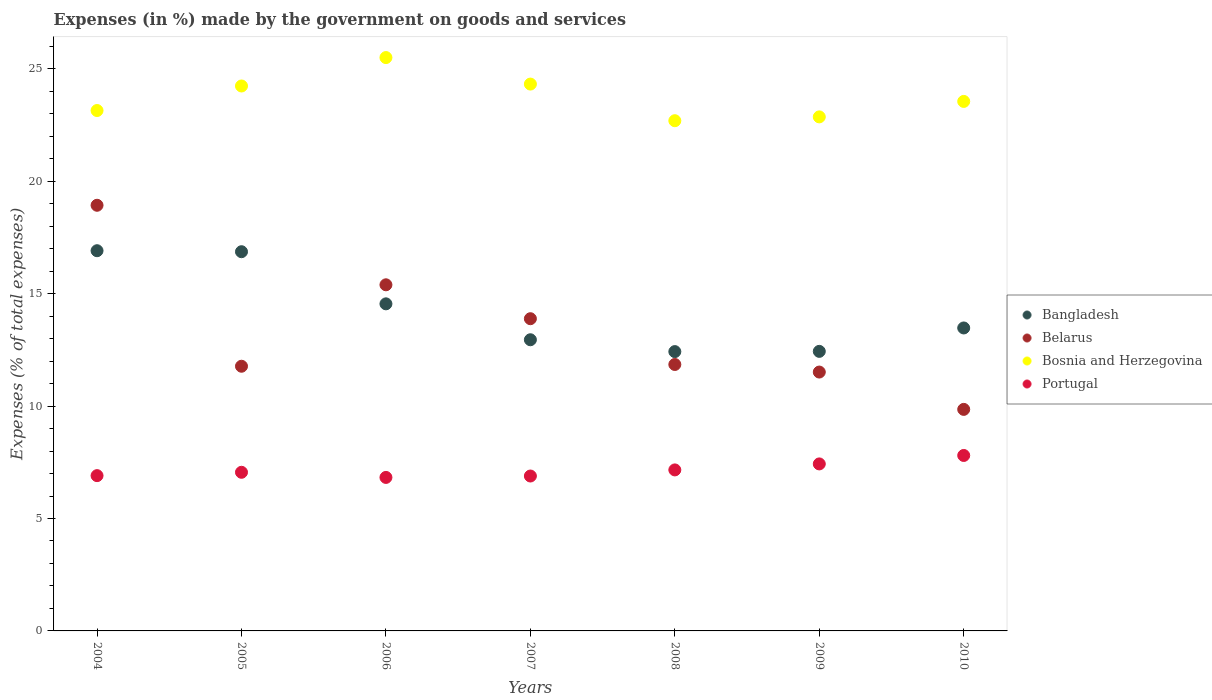Is the number of dotlines equal to the number of legend labels?
Your response must be concise. Yes. What is the percentage of expenses made by the government on goods and services in Belarus in 2007?
Your answer should be very brief. 13.89. Across all years, what is the maximum percentage of expenses made by the government on goods and services in Portugal?
Give a very brief answer. 7.8. Across all years, what is the minimum percentage of expenses made by the government on goods and services in Portugal?
Make the answer very short. 6.83. In which year was the percentage of expenses made by the government on goods and services in Bangladesh maximum?
Your answer should be compact. 2004. In which year was the percentage of expenses made by the government on goods and services in Belarus minimum?
Your response must be concise. 2010. What is the total percentage of expenses made by the government on goods and services in Bangladesh in the graph?
Offer a very short reply. 99.62. What is the difference between the percentage of expenses made by the government on goods and services in Portugal in 2004 and that in 2010?
Ensure brevity in your answer.  -0.9. What is the difference between the percentage of expenses made by the government on goods and services in Bangladesh in 2006 and the percentage of expenses made by the government on goods and services in Bosnia and Herzegovina in 2005?
Offer a very short reply. -9.69. What is the average percentage of expenses made by the government on goods and services in Belarus per year?
Keep it short and to the point. 13.32. In the year 2004, what is the difference between the percentage of expenses made by the government on goods and services in Portugal and percentage of expenses made by the government on goods and services in Bangladesh?
Provide a succinct answer. -10. What is the ratio of the percentage of expenses made by the government on goods and services in Portugal in 2004 to that in 2010?
Your response must be concise. 0.89. What is the difference between the highest and the second highest percentage of expenses made by the government on goods and services in Bangladesh?
Give a very brief answer. 0.04. What is the difference between the highest and the lowest percentage of expenses made by the government on goods and services in Bosnia and Herzegovina?
Offer a terse response. 2.81. In how many years, is the percentage of expenses made by the government on goods and services in Belarus greater than the average percentage of expenses made by the government on goods and services in Belarus taken over all years?
Your answer should be compact. 3. Is the sum of the percentage of expenses made by the government on goods and services in Belarus in 2005 and 2006 greater than the maximum percentage of expenses made by the government on goods and services in Bangladesh across all years?
Make the answer very short. Yes. Is it the case that in every year, the sum of the percentage of expenses made by the government on goods and services in Bosnia and Herzegovina and percentage of expenses made by the government on goods and services in Portugal  is greater than the sum of percentage of expenses made by the government on goods and services in Belarus and percentage of expenses made by the government on goods and services in Bangladesh?
Keep it short and to the point. Yes. Is the percentage of expenses made by the government on goods and services in Belarus strictly greater than the percentage of expenses made by the government on goods and services in Bosnia and Herzegovina over the years?
Your answer should be very brief. No. Is the percentage of expenses made by the government on goods and services in Portugal strictly less than the percentage of expenses made by the government on goods and services in Bosnia and Herzegovina over the years?
Keep it short and to the point. Yes. How many dotlines are there?
Offer a terse response. 4. What is the difference between two consecutive major ticks on the Y-axis?
Provide a short and direct response. 5. Are the values on the major ticks of Y-axis written in scientific E-notation?
Ensure brevity in your answer.  No. Does the graph contain any zero values?
Make the answer very short. No. Where does the legend appear in the graph?
Ensure brevity in your answer.  Center right. How many legend labels are there?
Your answer should be compact. 4. How are the legend labels stacked?
Keep it short and to the point. Vertical. What is the title of the graph?
Offer a terse response. Expenses (in %) made by the government on goods and services. Does "Ecuador" appear as one of the legend labels in the graph?
Give a very brief answer. No. What is the label or title of the Y-axis?
Ensure brevity in your answer.  Expenses (% of total expenses). What is the Expenses (% of total expenses) of Bangladesh in 2004?
Your answer should be very brief. 16.91. What is the Expenses (% of total expenses) of Belarus in 2004?
Offer a terse response. 18.93. What is the Expenses (% of total expenses) in Bosnia and Herzegovina in 2004?
Your answer should be very brief. 23.15. What is the Expenses (% of total expenses) of Portugal in 2004?
Your response must be concise. 6.91. What is the Expenses (% of total expenses) in Bangladesh in 2005?
Your response must be concise. 16.87. What is the Expenses (% of total expenses) of Belarus in 2005?
Your answer should be very brief. 11.77. What is the Expenses (% of total expenses) of Bosnia and Herzegovina in 2005?
Give a very brief answer. 24.24. What is the Expenses (% of total expenses) of Portugal in 2005?
Keep it short and to the point. 7.06. What is the Expenses (% of total expenses) of Bangladesh in 2006?
Ensure brevity in your answer.  14.55. What is the Expenses (% of total expenses) in Belarus in 2006?
Give a very brief answer. 15.4. What is the Expenses (% of total expenses) of Bosnia and Herzegovina in 2006?
Provide a succinct answer. 25.5. What is the Expenses (% of total expenses) of Portugal in 2006?
Keep it short and to the point. 6.83. What is the Expenses (% of total expenses) of Bangladesh in 2007?
Your response must be concise. 12.95. What is the Expenses (% of total expenses) of Belarus in 2007?
Offer a terse response. 13.89. What is the Expenses (% of total expenses) of Bosnia and Herzegovina in 2007?
Offer a terse response. 24.32. What is the Expenses (% of total expenses) of Portugal in 2007?
Give a very brief answer. 6.89. What is the Expenses (% of total expenses) in Bangladesh in 2008?
Offer a very short reply. 12.42. What is the Expenses (% of total expenses) of Belarus in 2008?
Your response must be concise. 11.85. What is the Expenses (% of total expenses) in Bosnia and Herzegovina in 2008?
Keep it short and to the point. 22.7. What is the Expenses (% of total expenses) of Portugal in 2008?
Your response must be concise. 7.16. What is the Expenses (% of total expenses) in Bangladesh in 2009?
Your response must be concise. 12.44. What is the Expenses (% of total expenses) in Belarus in 2009?
Your response must be concise. 11.51. What is the Expenses (% of total expenses) in Bosnia and Herzegovina in 2009?
Offer a very short reply. 22.87. What is the Expenses (% of total expenses) of Portugal in 2009?
Ensure brevity in your answer.  7.43. What is the Expenses (% of total expenses) in Bangladesh in 2010?
Your answer should be very brief. 13.48. What is the Expenses (% of total expenses) of Belarus in 2010?
Your answer should be very brief. 9.85. What is the Expenses (% of total expenses) of Bosnia and Herzegovina in 2010?
Ensure brevity in your answer.  23.55. What is the Expenses (% of total expenses) of Portugal in 2010?
Keep it short and to the point. 7.8. Across all years, what is the maximum Expenses (% of total expenses) of Bangladesh?
Your answer should be very brief. 16.91. Across all years, what is the maximum Expenses (% of total expenses) in Belarus?
Make the answer very short. 18.93. Across all years, what is the maximum Expenses (% of total expenses) of Bosnia and Herzegovina?
Offer a very short reply. 25.5. Across all years, what is the maximum Expenses (% of total expenses) of Portugal?
Offer a terse response. 7.8. Across all years, what is the minimum Expenses (% of total expenses) of Bangladesh?
Provide a short and direct response. 12.42. Across all years, what is the minimum Expenses (% of total expenses) of Belarus?
Offer a very short reply. 9.85. Across all years, what is the minimum Expenses (% of total expenses) in Bosnia and Herzegovina?
Provide a short and direct response. 22.7. Across all years, what is the minimum Expenses (% of total expenses) in Portugal?
Provide a succinct answer. 6.83. What is the total Expenses (% of total expenses) of Bangladesh in the graph?
Your response must be concise. 99.62. What is the total Expenses (% of total expenses) in Belarus in the graph?
Keep it short and to the point. 93.21. What is the total Expenses (% of total expenses) of Bosnia and Herzegovina in the graph?
Make the answer very short. 166.33. What is the total Expenses (% of total expenses) in Portugal in the graph?
Keep it short and to the point. 50.08. What is the difference between the Expenses (% of total expenses) of Bangladesh in 2004 and that in 2005?
Your response must be concise. 0.04. What is the difference between the Expenses (% of total expenses) of Belarus in 2004 and that in 2005?
Offer a very short reply. 7.16. What is the difference between the Expenses (% of total expenses) in Bosnia and Herzegovina in 2004 and that in 2005?
Provide a short and direct response. -1.09. What is the difference between the Expenses (% of total expenses) in Portugal in 2004 and that in 2005?
Provide a succinct answer. -0.15. What is the difference between the Expenses (% of total expenses) in Bangladesh in 2004 and that in 2006?
Your answer should be very brief. 2.36. What is the difference between the Expenses (% of total expenses) of Belarus in 2004 and that in 2006?
Give a very brief answer. 3.54. What is the difference between the Expenses (% of total expenses) in Bosnia and Herzegovina in 2004 and that in 2006?
Offer a terse response. -2.36. What is the difference between the Expenses (% of total expenses) in Portugal in 2004 and that in 2006?
Your answer should be compact. 0.08. What is the difference between the Expenses (% of total expenses) of Bangladesh in 2004 and that in 2007?
Offer a terse response. 3.96. What is the difference between the Expenses (% of total expenses) of Belarus in 2004 and that in 2007?
Offer a terse response. 5.05. What is the difference between the Expenses (% of total expenses) of Bosnia and Herzegovina in 2004 and that in 2007?
Keep it short and to the point. -1.18. What is the difference between the Expenses (% of total expenses) of Portugal in 2004 and that in 2007?
Your answer should be very brief. 0.02. What is the difference between the Expenses (% of total expenses) in Bangladesh in 2004 and that in 2008?
Offer a terse response. 4.49. What is the difference between the Expenses (% of total expenses) of Belarus in 2004 and that in 2008?
Keep it short and to the point. 7.08. What is the difference between the Expenses (% of total expenses) in Bosnia and Herzegovina in 2004 and that in 2008?
Offer a very short reply. 0.45. What is the difference between the Expenses (% of total expenses) in Portugal in 2004 and that in 2008?
Your answer should be very brief. -0.25. What is the difference between the Expenses (% of total expenses) of Bangladesh in 2004 and that in 2009?
Offer a terse response. 4.48. What is the difference between the Expenses (% of total expenses) in Belarus in 2004 and that in 2009?
Your answer should be compact. 7.42. What is the difference between the Expenses (% of total expenses) of Bosnia and Herzegovina in 2004 and that in 2009?
Make the answer very short. 0.28. What is the difference between the Expenses (% of total expenses) in Portugal in 2004 and that in 2009?
Ensure brevity in your answer.  -0.52. What is the difference between the Expenses (% of total expenses) of Bangladesh in 2004 and that in 2010?
Provide a short and direct response. 3.44. What is the difference between the Expenses (% of total expenses) of Belarus in 2004 and that in 2010?
Your answer should be very brief. 9.08. What is the difference between the Expenses (% of total expenses) in Bosnia and Herzegovina in 2004 and that in 2010?
Your answer should be very brief. -0.41. What is the difference between the Expenses (% of total expenses) in Portugal in 2004 and that in 2010?
Make the answer very short. -0.9. What is the difference between the Expenses (% of total expenses) of Bangladesh in 2005 and that in 2006?
Ensure brevity in your answer.  2.32. What is the difference between the Expenses (% of total expenses) of Belarus in 2005 and that in 2006?
Offer a very short reply. -3.62. What is the difference between the Expenses (% of total expenses) of Bosnia and Herzegovina in 2005 and that in 2006?
Make the answer very short. -1.26. What is the difference between the Expenses (% of total expenses) in Portugal in 2005 and that in 2006?
Provide a succinct answer. 0.23. What is the difference between the Expenses (% of total expenses) in Bangladesh in 2005 and that in 2007?
Give a very brief answer. 3.92. What is the difference between the Expenses (% of total expenses) of Belarus in 2005 and that in 2007?
Make the answer very short. -2.11. What is the difference between the Expenses (% of total expenses) in Bosnia and Herzegovina in 2005 and that in 2007?
Offer a terse response. -0.08. What is the difference between the Expenses (% of total expenses) in Portugal in 2005 and that in 2007?
Keep it short and to the point. 0.17. What is the difference between the Expenses (% of total expenses) of Bangladesh in 2005 and that in 2008?
Your answer should be very brief. 4.44. What is the difference between the Expenses (% of total expenses) of Belarus in 2005 and that in 2008?
Your answer should be compact. -0.08. What is the difference between the Expenses (% of total expenses) of Bosnia and Herzegovina in 2005 and that in 2008?
Your answer should be very brief. 1.54. What is the difference between the Expenses (% of total expenses) of Portugal in 2005 and that in 2008?
Your response must be concise. -0.11. What is the difference between the Expenses (% of total expenses) of Bangladesh in 2005 and that in 2009?
Your answer should be very brief. 4.43. What is the difference between the Expenses (% of total expenses) in Belarus in 2005 and that in 2009?
Ensure brevity in your answer.  0.26. What is the difference between the Expenses (% of total expenses) in Bosnia and Herzegovina in 2005 and that in 2009?
Give a very brief answer. 1.37. What is the difference between the Expenses (% of total expenses) in Portugal in 2005 and that in 2009?
Your response must be concise. -0.37. What is the difference between the Expenses (% of total expenses) in Bangladesh in 2005 and that in 2010?
Provide a short and direct response. 3.39. What is the difference between the Expenses (% of total expenses) of Belarus in 2005 and that in 2010?
Your response must be concise. 1.92. What is the difference between the Expenses (% of total expenses) in Bosnia and Herzegovina in 2005 and that in 2010?
Your response must be concise. 0.69. What is the difference between the Expenses (% of total expenses) of Portugal in 2005 and that in 2010?
Give a very brief answer. -0.75. What is the difference between the Expenses (% of total expenses) in Bangladesh in 2006 and that in 2007?
Ensure brevity in your answer.  1.6. What is the difference between the Expenses (% of total expenses) in Belarus in 2006 and that in 2007?
Ensure brevity in your answer.  1.51. What is the difference between the Expenses (% of total expenses) in Bosnia and Herzegovina in 2006 and that in 2007?
Make the answer very short. 1.18. What is the difference between the Expenses (% of total expenses) in Portugal in 2006 and that in 2007?
Offer a terse response. -0.06. What is the difference between the Expenses (% of total expenses) in Bangladesh in 2006 and that in 2008?
Your answer should be very brief. 2.12. What is the difference between the Expenses (% of total expenses) of Belarus in 2006 and that in 2008?
Give a very brief answer. 3.54. What is the difference between the Expenses (% of total expenses) in Bosnia and Herzegovina in 2006 and that in 2008?
Provide a succinct answer. 2.81. What is the difference between the Expenses (% of total expenses) of Portugal in 2006 and that in 2008?
Offer a terse response. -0.33. What is the difference between the Expenses (% of total expenses) in Bangladesh in 2006 and that in 2009?
Your answer should be very brief. 2.11. What is the difference between the Expenses (% of total expenses) of Belarus in 2006 and that in 2009?
Your answer should be very brief. 3.88. What is the difference between the Expenses (% of total expenses) in Bosnia and Herzegovina in 2006 and that in 2009?
Provide a succinct answer. 2.64. What is the difference between the Expenses (% of total expenses) in Portugal in 2006 and that in 2009?
Give a very brief answer. -0.6. What is the difference between the Expenses (% of total expenses) of Bangladesh in 2006 and that in 2010?
Make the answer very short. 1.07. What is the difference between the Expenses (% of total expenses) in Belarus in 2006 and that in 2010?
Provide a short and direct response. 5.54. What is the difference between the Expenses (% of total expenses) of Bosnia and Herzegovina in 2006 and that in 2010?
Offer a terse response. 1.95. What is the difference between the Expenses (% of total expenses) in Portugal in 2006 and that in 2010?
Give a very brief answer. -0.98. What is the difference between the Expenses (% of total expenses) in Bangladesh in 2007 and that in 2008?
Provide a short and direct response. 0.53. What is the difference between the Expenses (% of total expenses) of Belarus in 2007 and that in 2008?
Offer a very short reply. 2.04. What is the difference between the Expenses (% of total expenses) in Bosnia and Herzegovina in 2007 and that in 2008?
Keep it short and to the point. 1.63. What is the difference between the Expenses (% of total expenses) in Portugal in 2007 and that in 2008?
Your answer should be compact. -0.27. What is the difference between the Expenses (% of total expenses) in Bangladesh in 2007 and that in 2009?
Your response must be concise. 0.52. What is the difference between the Expenses (% of total expenses) in Belarus in 2007 and that in 2009?
Make the answer very short. 2.37. What is the difference between the Expenses (% of total expenses) in Bosnia and Herzegovina in 2007 and that in 2009?
Make the answer very short. 1.46. What is the difference between the Expenses (% of total expenses) in Portugal in 2007 and that in 2009?
Make the answer very short. -0.54. What is the difference between the Expenses (% of total expenses) in Bangladesh in 2007 and that in 2010?
Provide a short and direct response. -0.52. What is the difference between the Expenses (% of total expenses) of Belarus in 2007 and that in 2010?
Provide a short and direct response. 4.03. What is the difference between the Expenses (% of total expenses) in Bosnia and Herzegovina in 2007 and that in 2010?
Provide a succinct answer. 0.77. What is the difference between the Expenses (% of total expenses) in Portugal in 2007 and that in 2010?
Your answer should be compact. -0.91. What is the difference between the Expenses (% of total expenses) of Bangladesh in 2008 and that in 2009?
Ensure brevity in your answer.  -0.01. What is the difference between the Expenses (% of total expenses) of Belarus in 2008 and that in 2009?
Your answer should be compact. 0.34. What is the difference between the Expenses (% of total expenses) of Bosnia and Herzegovina in 2008 and that in 2009?
Your answer should be very brief. -0.17. What is the difference between the Expenses (% of total expenses) of Portugal in 2008 and that in 2009?
Ensure brevity in your answer.  -0.27. What is the difference between the Expenses (% of total expenses) in Bangladesh in 2008 and that in 2010?
Provide a succinct answer. -1.05. What is the difference between the Expenses (% of total expenses) of Belarus in 2008 and that in 2010?
Your response must be concise. 2. What is the difference between the Expenses (% of total expenses) of Bosnia and Herzegovina in 2008 and that in 2010?
Ensure brevity in your answer.  -0.86. What is the difference between the Expenses (% of total expenses) of Portugal in 2008 and that in 2010?
Make the answer very short. -0.64. What is the difference between the Expenses (% of total expenses) in Bangladesh in 2009 and that in 2010?
Keep it short and to the point. -1.04. What is the difference between the Expenses (% of total expenses) of Belarus in 2009 and that in 2010?
Your response must be concise. 1.66. What is the difference between the Expenses (% of total expenses) in Bosnia and Herzegovina in 2009 and that in 2010?
Your answer should be very brief. -0.69. What is the difference between the Expenses (% of total expenses) of Portugal in 2009 and that in 2010?
Make the answer very short. -0.38. What is the difference between the Expenses (% of total expenses) in Bangladesh in 2004 and the Expenses (% of total expenses) in Belarus in 2005?
Ensure brevity in your answer.  5.14. What is the difference between the Expenses (% of total expenses) in Bangladesh in 2004 and the Expenses (% of total expenses) in Bosnia and Herzegovina in 2005?
Your answer should be compact. -7.33. What is the difference between the Expenses (% of total expenses) of Bangladesh in 2004 and the Expenses (% of total expenses) of Portugal in 2005?
Ensure brevity in your answer.  9.86. What is the difference between the Expenses (% of total expenses) of Belarus in 2004 and the Expenses (% of total expenses) of Bosnia and Herzegovina in 2005?
Your answer should be compact. -5.31. What is the difference between the Expenses (% of total expenses) in Belarus in 2004 and the Expenses (% of total expenses) in Portugal in 2005?
Your response must be concise. 11.88. What is the difference between the Expenses (% of total expenses) in Bosnia and Herzegovina in 2004 and the Expenses (% of total expenses) in Portugal in 2005?
Provide a short and direct response. 16.09. What is the difference between the Expenses (% of total expenses) in Bangladesh in 2004 and the Expenses (% of total expenses) in Belarus in 2006?
Your answer should be very brief. 1.52. What is the difference between the Expenses (% of total expenses) in Bangladesh in 2004 and the Expenses (% of total expenses) in Bosnia and Herzegovina in 2006?
Make the answer very short. -8.59. What is the difference between the Expenses (% of total expenses) of Bangladesh in 2004 and the Expenses (% of total expenses) of Portugal in 2006?
Your answer should be compact. 10.08. What is the difference between the Expenses (% of total expenses) of Belarus in 2004 and the Expenses (% of total expenses) of Bosnia and Herzegovina in 2006?
Make the answer very short. -6.57. What is the difference between the Expenses (% of total expenses) in Belarus in 2004 and the Expenses (% of total expenses) in Portugal in 2006?
Offer a terse response. 12.11. What is the difference between the Expenses (% of total expenses) in Bosnia and Herzegovina in 2004 and the Expenses (% of total expenses) in Portugal in 2006?
Your answer should be very brief. 16.32. What is the difference between the Expenses (% of total expenses) in Bangladesh in 2004 and the Expenses (% of total expenses) in Belarus in 2007?
Make the answer very short. 3.02. What is the difference between the Expenses (% of total expenses) of Bangladesh in 2004 and the Expenses (% of total expenses) of Bosnia and Herzegovina in 2007?
Keep it short and to the point. -7.41. What is the difference between the Expenses (% of total expenses) of Bangladesh in 2004 and the Expenses (% of total expenses) of Portugal in 2007?
Offer a very short reply. 10.02. What is the difference between the Expenses (% of total expenses) in Belarus in 2004 and the Expenses (% of total expenses) in Bosnia and Herzegovina in 2007?
Offer a very short reply. -5.39. What is the difference between the Expenses (% of total expenses) in Belarus in 2004 and the Expenses (% of total expenses) in Portugal in 2007?
Your answer should be very brief. 12.04. What is the difference between the Expenses (% of total expenses) in Bosnia and Herzegovina in 2004 and the Expenses (% of total expenses) in Portugal in 2007?
Offer a very short reply. 16.26. What is the difference between the Expenses (% of total expenses) in Bangladesh in 2004 and the Expenses (% of total expenses) in Belarus in 2008?
Keep it short and to the point. 5.06. What is the difference between the Expenses (% of total expenses) of Bangladesh in 2004 and the Expenses (% of total expenses) of Bosnia and Herzegovina in 2008?
Your response must be concise. -5.78. What is the difference between the Expenses (% of total expenses) of Bangladesh in 2004 and the Expenses (% of total expenses) of Portugal in 2008?
Keep it short and to the point. 9.75. What is the difference between the Expenses (% of total expenses) in Belarus in 2004 and the Expenses (% of total expenses) in Bosnia and Herzegovina in 2008?
Make the answer very short. -3.76. What is the difference between the Expenses (% of total expenses) of Belarus in 2004 and the Expenses (% of total expenses) of Portugal in 2008?
Your answer should be compact. 11.77. What is the difference between the Expenses (% of total expenses) of Bosnia and Herzegovina in 2004 and the Expenses (% of total expenses) of Portugal in 2008?
Provide a succinct answer. 15.99. What is the difference between the Expenses (% of total expenses) of Bangladesh in 2004 and the Expenses (% of total expenses) of Belarus in 2009?
Keep it short and to the point. 5.4. What is the difference between the Expenses (% of total expenses) of Bangladesh in 2004 and the Expenses (% of total expenses) of Bosnia and Herzegovina in 2009?
Provide a succinct answer. -5.95. What is the difference between the Expenses (% of total expenses) in Bangladesh in 2004 and the Expenses (% of total expenses) in Portugal in 2009?
Provide a succinct answer. 9.48. What is the difference between the Expenses (% of total expenses) in Belarus in 2004 and the Expenses (% of total expenses) in Bosnia and Herzegovina in 2009?
Your response must be concise. -3.93. What is the difference between the Expenses (% of total expenses) in Belarus in 2004 and the Expenses (% of total expenses) in Portugal in 2009?
Provide a short and direct response. 11.51. What is the difference between the Expenses (% of total expenses) in Bosnia and Herzegovina in 2004 and the Expenses (% of total expenses) in Portugal in 2009?
Offer a very short reply. 15.72. What is the difference between the Expenses (% of total expenses) of Bangladesh in 2004 and the Expenses (% of total expenses) of Belarus in 2010?
Offer a terse response. 7.06. What is the difference between the Expenses (% of total expenses) of Bangladesh in 2004 and the Expenses (% of total expenses) of Bosnia and Herzegovina in 2010?
Ensure brevity in your answer.  -6.64. What is the difference between the Expenses (% of total expenses) of Bangladesh in 2004 and the Expenses (% of total expenses) of Portugal in 2010?
Your answer should be very brief. 9.11. What is the difference between the Expenses (% of total expenses) of Belarus in 2004 and the Expenses (% of total expenses) of Bosnia and Herzegovina in 2010?
Give a very brief answer. -4.62. What is the difference between the Expenses (% of total expenses) of Belarus in 2004 and the Expenses (% of total expenses) of Portugal in 2010?
Provide a succinct answer. 11.13. What is the difference between the Expenses (% of total expenses) in Bosnia and Herzegovina in 2004 and the Expenses (% of total expenses) in Portugal in 2010?
Make the answer very short. 15.34. What is the difference between the Expenses (% of total expenses) of Bangladesh in 2005 and the Expenses (% of total expenses) of Belarus in 2006?
Offer a terse response. 1.47. What is the difference between the Expenses (% of total expenses) of Bangladesh in 2005 and the Expenses (% of total expenses) of Bosnia and Herzegovina in 2006?
Your response must be concise. -8.64. What is the difference between the Expenses (% of total expenses) in Bangladesh in 2005 and the Expenses (% of total expenses) in Portugal in 2006?
Your answer should be very brief. 10.04. What is the difference between the Expenses (% of total expenses) of Belarus in 2005 and the Expenses (% of total expenses) of Bosnia and Herzegovina in 2006?
Offer a very short reply. -13.73. What is the difference between the Expenses (% of total expenses) of Belarus in 2005 and the Expenses (% of total expenses) of Portugal in 2006?
Provide a short and direct response. 4.95. What is the difference between the Expenses (% of total expenses) of Bosnia and Herzegovina in 2005 and the Expenses (% of total expenses) of Portugal in 2006?
Give a very brief answer. 17.41. What is the difference between the Expenses (% of total expenses) in Bangladesh in 2005 and the Expenses (% of total expenses) in Belarus in 2007?
Provide a short and direct response. 2.98. What is the difference between the Expenses (% of total expenses) of Bangladesh in 2005 and the Expenses (% of total expenses) of Bosnia and Herzegovina in 2007?
Your response must be concise. -7.46. What is the difference between the Expenses (% of total expenses) in Bangladesh in 2005 and the Expenses (% of total expenses) in Portugal in 2007?
Ensure brevity in your answer.  9.98. What is the difference between the Expenses (% of total expenses) in Belarus in 2005 and the Expenses (% of total expenses) in Bosnia and Herzegovina in 2007?
Keep it short and to the point. -12.55. What is the difference between the Expenses (% of total expenses) in Belarus in 2005 and the Expenses (% of total expenses) in Portugal in 2007?
Offer a terse response. 4.88. What is the difference between the Expenses (% of total expenses) in Bosnia and Herzegovina in 2005 and the Expenses (% of total expenses) in Portugal in 2007?
Provide a short and direct response. 17.35. What is the difference between the Expenses (% of total expenses) in Bangladesh in 2005 and the Expenses (% of total expenses) in Belarus in 2008?
Provide a short and direct response. 5.02. What is the difference between the Expenses (% of total expenses) of Bangladesh in 2005 and the Expenses (% of total expenses) of Bosnia and Herzegovina in 2008?
Offer a very short reply. -5.83. What is the difference between the Expenses (% of total expenses) in Bangladesh in 2005 and the Expenses (% of total expenses) in Portugal in 2008?
Make the answer very short. 9.71. What is the difference between the Expenses (% of total expenses) of Belarus in 2005 and the Expenses (% of total expenses) of Bosnia and Herzegovina in 2008?
Provide a short and direct response. -10.92. What is the difference between the Expenses (% of total expenses) in Belarus in 2005 and the Expenses (% of total expenses) in Portugal in 2008?
Offer a terse response. 4.61. What is the difference between the Expenses (% of total expenses) in Bosnia and Herzegovina in 2005 and the Expenses (% of total expenses) in Portugal in 2008?
Give a very brief answer. 17.08. What is the difference between the Expenses (% of total expenses) in Bangladesh in 2005 and the Expenses (% of total expenses) in Belarus in 2009?
Provide a short and direct response. 5.35. What is the difference between the Expenses (% of total expenses) in Bangladesh in 2005 and the Expenses (% of total expenses) in Bosnia and Herzegovina in 2009?
Offer a very short reply. -6. What is the difference between the Expenses (% of total expenses) of Bangladesh in 2005 and the Expenses (% of total expenses) of Portugal in 2009?
Make the answer very short. 9.44. What is the difference between the Expenses (% of total expenses) in Belarus in 2005 and the Expenses (% of total expenses) in Bosnia and Herzegovina in 2009?
Provide a short and direct response. -11.09. What is the difference between the Expenses (% of total expenses) of Belarus in 2005 and the Expenses (% of total expenses) of Portugal in 2009?
Ensure brevity in your answer.  4.34. What is the difference between the Expenses (% of total expenses) in Bosnia and Herzegovina in 2005 and the Expenses (% of total expenses) in Portugal in 2009?
Ensure brevity in your answer.  16.81. What is the difference between the Expenses (% of total expenses) of Bangladesh in 2005 and the Expenses (% of total expenses) of Belarus in 2010?
Make the answer very short. 7.01. What is the difference between the Expenses (% of total expenses) in Bangladesh in 2005 and the Expenses (% of total expenses) in Bosnia and Herzegovina in 2010?
Your answer should be very brief. -6.69. What is the difference between the Expenses (% of total expenses) of Bangladesh in 2005 and the Expenses (% of total expenses) of Portugal in 2010?
Offer a very short reply. 9.06. What is the difference between the Expenses (% of total expenses) in Belarus in 2005 and the Expenses (% of total expenses) in Bosnia and Herzegovina in 2010?
Offer a terse response. -11.78. What is the difference between the Expenses (% of total expenses) of Belarus in 2005 and the Expenses (% of total expenses) of Portugal in 2010?
Your answer should be very brief. 3.97. What is the difference between the Expenses (% of total expenses) in Bosnia and Herzegovina in 2005 and the Expenses (% of total expenses) in Portugal in 2010?
Your response must be concise. 16.44. What is the difference between the Expenses (% of total expenses) of Bangladesh in 2006 and the Expenses (% of total expenses) of Belarus in 2007?
Make the answer very short. 0.66. What is the difference between the Expenses (% of total expenses) of Bangladesh in 2006 and the Expenses (% of total expenses) of Bosnia and Herzegovina in 2007?
Make the answer very short. -9.78. What is the difference between the Expenses (% of total expenses) in Bangladesh in 2006 and the Expenses (% of total expenses) in Portugal in 2007?
Offer a terse response. 7.66. What is the difference between the Expenses (% of total expenses) of Belarus in 2006 and the Expenses (% of total expenses) of Bosnia and Herzegovina in 2007?
Offer a very short reply. -8.93. What is the difference between the Expenses (% of total expenses) of Belarus in 2006 and the Expenses (% of total expenses) of Portugal in 2007?
Offer a terse response. 8.51. What is the difference between the Expenses (% of total expenses) of Bosnia and Herzegovina in 2006 and the Expenses (% of total expenses) of Portugal in 2007?
Offer a terse response. 18.61. What is the difference between the Expenses (% of total expenses) in Bangladesh in 2006 and the Expenses (% of total expenses) in Belarus in 2008?
Offer a terse response. 2.7. What is the difference between the Expenses (% of total expenses) of Bangladesh in 2006 and the Expenses (% of total expenses) of Bosnia and Herzegovina in 2008?
Provide a short and direct response. -8.15. What is the difference between the Expenses (% of total expenses) in Bangladesh in 2006 and the Expenses (% of total expenses) in Portugal in 2008?
Offer a terse response. 7.39. What is the difference between the Expenses (% of total expenses) in Belarus in 2006 and the Expenses (% of total expenses) in Bosnia and Herzegovina in 2008?
Your answer should be very brief. -7.3. What is the difference between the Expenses (% of total expenses) of Belarus in 2006 and the Expenses (% of total expenses) of Portugal in 2008?
Provide a short and direct response. 8.23. What is the difference between the Expenses (% of total expenses) of Bosnia and Herzegovina in 2006 and the Expenses (% of total expenses) of Portugal in 2008?
Make the answer very short. 18.34. What is the difference between the Expenses (% of total expenses) in Bangladesh in 2006 and the Expenses (% of total expenses) in Belarus in 2009?
Your response must be concise. 3.03. What is the difference between the Expenses (% of total expenses) of Bangladesh in 2006 and the Expenses (% of total expenses) of Bosnia and Herzegovina in 2009?
Your response must be concise. -8.32. What is the difference between the Expenses (% of total expenses) of Bangladesh in 2006 and the Expenses (% of total expenses) of Portugal in 2009?
Make the answer very short. 7.12. What is the difference between the Expenses (% of total expenses) of Belarus in 2006 and the Expenses (% of total expenses) of Bosnia and Herzegovina in 2009?
Offer a terse response. -7.47. What is the difference between the Expenses (% of total expenses) in Belarus in 2006 and the Expenses (% of total expenses) in Portugal in 2009?
Your answer should be compact. 7.97. What is the difference between the Expenses (% of total expenses) in Bosnia and Herzegovina in 2006 and the Expenses (% of total expenses) in Portugal in 2009?
Provide a succinct answer. 18.08. What is the difference between the Expenses (% of total expenses) in Bangladesh in 2006 and the Expenses (% of total expenses) in Belarus in 2010?
Keep it short and to the point. 4.69. What is the difference between the Expenses (% of total expenses) of Bangladesh in 2006 and the Expenses (% of total expenses) of Bosnia and Herzegovina in 2010?
Provide a short and direct response. -9. What is the difference between the Expenses (% of total expenses) in Bangladesh in 2006 and the Expenses (% of total expenses) in Portugal in 2010?
Provide a succinct answer. 6.74. What is the difference between the Expenses (% of total expenses) of Belarus in 2006 and the Expenses (% of total expenses) of Bosnia and Herzegovina in 2010?
Your response must be concise. -8.16. What is the difference between the Expenses (% of total expenses) of Belarus in 2006 and the Expenses (% of total expenses) of Portugal in 2010?
Provide a short and direct response. 7.59. What is the difference between the Expenses (% of total expenses) of Bosnia and Herzegovina in 2006 and the Expenses (% of total expenses) of Portugal in 2010?
Keep it short and to the point. 17.7. What is the difference between the Expenses (% of total expenses) of Bangladesh in 2007 and the Expenses (% of total expenses) of Bosnia and Herzegovina in 2008?
Ensure brevity in your answer.  -9.74. What is the difference between the Expenses (% of total expenses) in Bangladesh in 2007 and the Expenses (% of total expenses) in Portugal in 2008?
Your answer should be compact. 5.79. What is the difference between the Expenses (% of total expenses) in Belarus in 2007 and the Expenses (% of total expenses) in Bosnia and Herzegovina in 2008?
Your answer should be compact. -8.81. What is the difference between the Expenses (% of total expenses) in Belarus in 2007 and the Expenses (% of total expenses) in Portugal in 2008?
Keep it short and to the point. 6.73. What is the difference between the Expenses (% of total expenses) of Bosnia and Herzegovina in 2007 and the Expenses (% of total expenses) of Portugal in 2008?
Your response must be concise. 17.16. What is the difference between the Expenses (% of total expenses) in Bangladesh in 2007 and the Expenses (% of total expenses) in Belarus in 2009?
Offer a very short reply. 1.44. What is the difference between the Expenses (% of total expenses) of Bangladesh in 2007 and the Expenses (% of total expenses) of Bosnia and Herzegovina in 2009?
Offer a very short reply. -9.91. What is the difference between the Expenses (% of total expenses) in Bangladesh in 2007 and the Expenses (% of total expenses) in Portugal in 2009?
Your response must be concise. 5.52. What is the difference between the Expenses (% of total expenses) in Belarus in 2007 and the Expenses (% of total expenses) in Bosnia and Herzegovina in 2009?
Your answer should be very brief. -8.98. What is the difference between the Expenses (% of total expenses) in Belarus in 2007 and the Expenses (% of total expenses) in Portugal in 2009?
Provide a succinct answer. 6.46. What is the difference between the Expenses (% of total expenses) in Bosnia and Herzegovina in 2007 and the Expenses (% of total expenses) in Portugal in 2009?
Make the answer very short. 16.9. What is the difference between the Expenses (% of total expenses) in Bangladesh in 2007 and the Expenses (% of total expenses) in Belarus in 2010?
Provide a short and direct response. 3.1. What is the difference between the Expenses (% of total expenses) of Bangladesh in 2007 and the Expenses (% of total expenses) of Bosnia and Herzegovina in 2010?
Keep it short and to the point. -10.6. What is the difference between the Expenses (% of total expenses) of Bangladesh in 2007 and the Expenses (% of total expenses) of Portugal in 2010?
Keep it short and to the point. 5.15. What is the difference between the Expenses (% of total expenses) in Belarus in 2007 and the Expenses (% of total expenses) in Bosnia and Herzegovina in 2010?
Make the answer very short. -9.67. What is the difference between the Expenses (% of total expenses) in Belarus in 2007 and the Expenses (% of total expenses) in Portugal in 2010?
Offer a very short reply. 6.08. What is the difference between the Expenses (% of total expenses) of Bosnia and Herzegovina in 2007 and the Expenses (% of total expenses) of Portugal in 2010?
Offer a very short reply. 16.52. What is the difference between the Expenses (% of total expenses) in Bangladesh in 2008 and the Expenses (% of total expenses) in Belarus in 2009?
Your response must be concise. 0.91. What is the difference between the Expenses (% of total expenses) of Bangladesh in 2008 and the Expenses (% of total expenses) of Bosnia and Herzegovina in 2009?
Offer a terse response. -10.44. What is the difference between the Expenses (% of total expenses) in Bangladesh in 2008 and the Expenses (% of total expenses) in Portugal in 2009?
Give a very brief answer. 5. What is the difference between the Expenses (% of total expenses) of Belarus in 2008 and the Expenses (% of total expenses) of Bosnia and Herzegovina in 2009?
Your answer should be very brief. -11.01. What is the difference between the Expenses (% of total expenses) in Belarus in 2008 and the Expenses (% of total expenses) in Portugal in 2009?
Offer a very short reply. 4.42. What is the difference between the Expenses (% of total expenses) in Bosnia and Herzegovina in 2008 and the Expenses (% of total expenses) in Portugal in 2009?
Provide a succinct answer. 15.27. What is the difference between the Expenses (% of total expenses) of Bangladesh in 2008 and the Expenses (% of total expenses) of Belarus in 2010?
Your answer should be compact. 2.57. What is the difference between the Expenses (% of total expenses) of Bangladesh in 2008 and the Expenses (% of total expenses) of Bosnia and Herzegovina in 2010?
Offer a very short reply. -11.13. What is the difference between the Expenses (% of total expenses) in Bangladesh in 2008 and the Expenses (% of total expenses) in Portugal in 2010?
Ensure brevity in your answer.  4.62. What is the difference between the Expenses (% of total expenses) of Belarus in 2008 and the Expenses (% of total expenses) of Bosnia and Herzegovina in 2010?
Your response must be concise. -11.7. What is the difference between the Expenses (% of total expenses) of Belarus in 2008 and the Expenses (% of total expenses) of Portugal in 2010?
Offer a terse response. 4.05. What is the difference between the Expenses (% of total expenses) of Bosnia and Herzegovina in 2008 and the Expenses (% of total expenses) of Portugal in 2010?
Give a very brief answer. 14.89. What is the difference between the Expenses (% of total expenses) in Bangladesh in 2009 and the Expenses (% of total expenses) in Belarus in 2010?
Give a very brief answer. 2.58. What is the difference between the Expenses (% of total expenses) in Bangladesh in 2009 and the Expenses (% of total expenses) in Bosnia and Herzegovina in 2010?
Make the answer very short. -11.12. What is the difference between the Expenses (% of total expenses) of Bangladesh in 2009 and the Expenses (% of total expenses) of Portugal in 2010?
Make the answer very short. 4.63. What is the difference between the Expenses (% of total expenses) in Belarus in 2009 and the Expenses (% of total expenses) in Bosnia and Herzegovina in 2010?
Provide a succinct answer. -12.04. What is the difference between the Expenses (% of total expenses) in Belarus in 2009 and the Expenses (% of total expenses) in Portugal in 2010?
Give a very brief answer. 3.71. What is the difference between the Expenses (% of total expenses) of Bosnia and Herzegovina in 2009 and the Expenses (% of total expenses) of Portugal in 2010?
Your response must be concise. 15.06. What is the average Expenses (% of total expenses) in Bangladesh per year?
Offer a terse response. 14.23. What is the average Expenses (% of total expenses) of Belarus per year?
Your response must be concise. 13.32. What is the average Expenses (% of total expenses) in Bosnia and Herzegovina per year?
Provide a short and direct response. 23.76. What is the average Expenses (% of total expenses) in Portugal per year?
Provide a succinct answer. 7.15. In the year 2004, what is the difference between the Expenses (% of total expenses) in Bangladesh and Expenses (% of total expenses) in Belarus?
Your answer should be compact. -2.02. In the year 2004, what is the difference between the Expenses (% of total expenses) of Bangladesh and Expenses (% of total expenses) of Bosnia and Herzegovina?
Provide a succinct answer. -6.24. In the year 2004, what is the difference between the Expenses (% of total expenses) of Bangladesh and Expenses (% of total expenses) of Portugal?
Keep it short and to the point. 10. In the year 2004, what is the difference between the Expenses (% of total expenses) of Belarus and Expenses (% of total expenses) of Bosnia and Herzegovina?
Ensure brevity in your answer.  -4.21. In the year 2004, what is the difference between the Expenses (% of total expenses) in Belarus and Expenses (% of total expenses) in Portugal?
Offer a very short reply. 12.03. In the year 2004, what is the difference between the Expenses (% of total expenses) in Bosnia and Herzegovina and Expenses (% of total expenses) in Portugal?
Your response must be concise. 16.24. In the year 2005, what is the difference between the Expenses (% of total expenses) in Bangladesh and Expenses (% of total expenses) in Belarus?
Provide a short and direct response. 5.09. In the year 2005, what is the difference between the Expenses (% of total expenses) in Bangladesh and Expenses (% of total expenses) in Bosnia and Herzegovina?
Your answer should be very brief. -7.37. In the year 2005, what is the difference between the Expenses (% of total expenses) of Bangladesh and Expenses (% of total expenses) of Portugal?
Your response must be concise. 9.81. In the year 2005, what is the difference between the Expenses (% of total expenses) of Belarus and Expenses (% of total expenses) of Bosnia and Herzegovina?
Give a very brief answer. -12.47. In the year 2005, what is the difference between the Expenses (% of total expenses) of Belarus and Expenses (% of total expenses) of Portugal?
Provide a succinct answer. 4.72. In the year 2005, what is the difference between the Expenses (% of total expenses) in Bosnia and Herzegovina and Expenses (% of total expenses) in Portugal?
Offer a very short reply. 17.18. In the year 2006, what is the difference between the Expenses (% of total expenses) in Bangladesh and Expenses (% of total expenses) in Belarus?
Provide a short and direct response. -0.85. In the year 2006, what is the difference between the Expenses (% of total expenses) of Bangladesh and Expenses (% of total expenses) of Bosnia and Herzegovina?
Your response must be concise. -10.95. In the year 2006, what is the difference between the Expenses (% of total expenses) of Bangladesh and Expenses (% of total expenses) of Portugal?
Ensure brevity in your answer.  7.72. In the year 2006, what is the difference between the Expenses (% of total expenses) in Belarus and Expenses (% of total expenses) in Bosnia and Herzegovina?
Give a very brief answer. -10.11. In the year 2006, what is the difference between the Expenses (% of total expenses) in Belarus and Expenses (% of total expenses) in Portugal?
Provide a short and direct response. 8.57. In the year 2006, what is the difference between the Expenses (% of total expenses) of Bosnia and Herzegovina and Expenses (% of total expenses) of Portugal?
Offer a terse response. 18.68. In the year 2007, what is the difference between the Expenses (% of total expenses) of Bangladesh and Expenses (% of total expenses) of Belarus?
Ensure brevity in your answer.  -0.94. In the year 2007, what is the difference between the Expenses (% of total expenses) of Bangladesh and Expenses (% of total expenses) of Bosnia and Herzegovina?
Give a very brief answer. -11.37. In the year 2007, what is the difference between the Expenses (% of total expenses) in Bangladesh and Expenses (% of total expenses) in Portugal?
Provide a succinct answer. 6.06. In the year 2007, what is the difference between the Expenses (% of total expenses) in Belarus and Expenses (% of total expenses) in Bosnia and Herzegovina?
Provide a short and direct response. -10.44. In the year 2007, what is the difference between the Expenses (% of total expenses) in Belarus and Expenses (% of total expenses) in Portugal?
Provide a short and direct response. 7. In the year 2007, what is the difference between the Expenses (% of total expenses) in Bosnia and Herzegovina and Expenses (% of total expenses) in Portugal?
Ensure brevity in your answer.  17.43. In the year 2008, what is the difference between the Expenses (% of total expenses) in Bangladesh and Expenses (% of total expenses) in Belarus?
Make the answer very short. 0.57. In the year 2008, what is the difference between the Expenses (% of total expenses) of Bangladesh and Expenses (% of total expenses) of Bosnia and Herzegovina?
Your response must be concise. -10.27. In the year 2008, what is the difference between the Expenses (% of total expenses) in Bangladesh and Expenses (% of total expenses) in Portugal?
Your response must be concise. 5.26. In the year 2008, what is the difference between the Expenses (% of total expenses) of Belarus and Expenses (% of total expenses) of Bosnia and Herzegovina?
Keep it short and to the point. -10.84. In the year 2008, what is the difference between the Expenses (% of total expenses) of Belarus and Expenses (% of total expenses) of Portugal?
Keep it short and to the point. 4.69. In the year 2008, what is the difference between the Expenses (% of total expenses) in Bosnia and Herzegovina and Expenses (% of total expenses) in Portugal?
Ensure brevity in your answer.  15.53. In the year 2009, what is the difference between the Expenses (% of total expenses) in Bangladesh and Expenses (% of total expenses) in Belarus?
Give a very brief answer. 0.92. In the year 2009, what is the difference between the Expenses (% of total expenses) of Bangladesh and Expenses (% of total expenses) of Bosnia and Herzegovina?
Make the answer very short. -10.43. In the year 2009, what is the difference between the Expenses (% of total expenses) of Bangladesh and Expenses (% of total expenses) of Portugal?
Give a very brief answer. 5.01. In the year 2009, what is the difference between the Expenses (% of total expenses) of Belarus and Expenses (% of total expenses) of Bosnia and Herzegovina?
Provide a short and direct response. -11.35. In the year 2009, what is the difference between the Expenses (% of total expenses) in Belarus and Expenses (% of total expenses) in Portugal?
Your answer should be compact. 4.09. In the year 2009, what is the difference between the Expenses (% of total expenses) of Bosnia and Herzegovina and Expenses (% of total expenses) of Portugal?
Provide a succinct answer. 15.44. In the year 2010, what is the difference between the Expenses (% of total expenses) of Bangladesh and Expenses (% of total expenses) of Belarus?
Make the answer very short. 3.62. In the year 2010, what is the difference between the Expenses (% of total expenses) in Bangladesh and Expenses (% of total expenses) in Bosnia and Herzegovina?
Your answer should be compact. -10.08. In the year 2010, what is the difference between the Expenses (% of total expenses) of Bangladesh and Expenses (% of total expenses) of Portugal?
Ensure brevity in your answer.  5.67. In the year 2010, what is the difference between the Expenses (% of total expenses) in Belarus and Expenses (% of total expenses) in Bosnia and Herzegovina?
Give a very brief answer. -13.7. In the year 2010, what is the difference between the Expenses (% of total expenses) in Belarus and Expenses (% of total expenses) in Portugal?
Give a very brief answer. 2.05. In the year 2010, what is the difference between the Expenses (% of total expenses) of Bosnia and Herzegovina and Expenses (% of total expenses) of Portugal?
Your answer should be compact. 15.75. What is the ratio of the Expenses (% of total expenses) of Bangladesh in 2004 to that in 2005?
Your response must be concise. 1. What is the ratio of the Expenses (% of total expenses) in Belarus in 2004 to that in 2005?
Make the answer very short. 1.61. What is the ratio of the Expenses (% of total expenses) in Bosnia and Herzegovina in 2004 to that in 2005?
Your answer should be very brief. 0.95. What is the ratio of the Expenses (% of total expenses) of Portugal in 2004 to that in 2005?
Your answer should be very brief. 0.98. What is the ratio of the Expenses (% of total expenses) in Bangladesh in 2004 to that in 2006?
Provide a succinct answer. 1.16. What is the ratio of the Expenses (% of total expenses) in Belarus in 2004 to that in 2006?
Offer a terse response. 1.23. What is the ratio of the Expenses (% of total expenses) of Bosnia and Herzegovina in 2004 to that in 2006?
Offer a very short reply. 0.91. What is the ratio of the Expenses (% of total expenses) of Portugal in 2004 to that in 2006?
Offer a terse response. 1.01. What is the ratio of the Expenses (% of total expenses) of Bangladesh in 2004 to that in 2007?
Make the answer very short. 1.31. What is the ratio of the Expenses (% of total expenses) in Belarus in 2004 to that in 2007?
Make the answer very short. 1.36. What is the ratio of the Expenses (% of total expenses) of Bosnia and Herzegovina in 2004 to that in 2007?
Provide a short and direct response. 0.95. What is the ratio of the Expenses (% of total expenses) of Portugal in 2004 to that in 2007?
Your answer should be compact. 1. What is the ratio of the Expenses (% of total expenses) in Bangladesh in 2004 to that in 2008?
Your response must be concise. 1.36. What is the ratio of the Expenses (% of total expenses) in Belarus in 2004 to that in 2008?
Give a very brief answer. 1.6. What is the ratio of the Expenses (% of total expenses) of Bosnia and Herzegovina in 2004 to that in 2008?
Make the answer very short. 1.02. What is the ratio of the Expenses (% of total expenses) in Portugal in 2004 to that in 2008?
Provide a short and direct response. 0.96. What is the ratio of the Expenses (% of total expenses) of Bangladesh in 2004 to that in 2009?
Provide a short and direct response. 1.36. What is the ratio of the Expenses (% of total expenses) of Belarus in 2004 to that in 2009?
Provide a succinct answer. 1.64. What is the ratio of the Expenses (% of total expenses) of Bosnia and Herzegovina in 2004 to that in 2009?
Offer a terse response. 1.01. What is the ratio of the Expenses (% of total expenses) of Portugal in 2004 to that in 2009?
Provide a short and direct response. 0.93. What is the ratio of the Expenses (% of total expenses) in Bangladesh in 2004 to that in 2010?
Provide a succinct answer. 1.25. What is the ratio of the Expenses (% of total expenses) in Belarus in 2004 to that in 2010?
Your answer should be very brief. 1.92. What is the ratio of the Expenses (% of total expenses) in Bosnia and Herzegovina in 2004 to that in 2010?
Keep it short and to the point. 0.98. What is the ratio of the Expenses (% of total expenses) of Portugal in 2004 to that in 2010?
Your answer should be compact. 0.89. What is the ratio of the Expenses (% of total expenses) in Bangladesh in 2005 to that in 2006?
Ensure brevity in your answer.  1.16. What is the ratio of the Expenses (% of total expenses) in Belarus in 2005 to that in 2006?
Ensure brevity in your answer.  0.76. What is the ratio of the Expenses (% of total expenses) in Bosnia and Herzegovina in 2005 to that in 2006?
Provide a short and direct response. 0.95. What is the ratio of the Expenses (% of total expenses) in Portugal in 2005 to that in 2006?
Ensure brevity in your answer.  1.03. What is the ratio of the Expenses (% of total expenses) of Bangladesh in 2005 to that in 2007?
Your response must be concise. 1.3. What is the ratio of the Expenses (% of total expenses) of Belarus in 2005 to that in 2007?
Provide a short and direct response. 0.85. What is the ratio of the Expenses (% of total expenses) in Bosnia and Herzegovina in 2005 to that in 2007?
Your answer should be compact. 1. What is the ratio of the Expenses (% of total expenses) in Portugal in 2005 to that in 2007?
Ensure brevity in your answer.  1.02. What is the ratio of the Expenses (% of total expenses) in Bangladesh in 2005 to that in 2008?
Offer a terse response. 1.36. What is the ratio of the Expenses (% of total expenses) in Bosnia and Herzegovina in 2005 to that in 2008?
Provide a succinct answer. 1.07. What is the ratio of the Expenses (% of total expenses) of Portugal in 2005 to that in 2008?
Your answer should be very brief. 0.99. What is the ratio of the Expenses (% of total expenses) in Bangladesh in 2005 to that in 2009?
Offer a very short reply. 1.36. What is the ratio of the Expenses (% of total expenses) in Belarus in 2005 to that in 2009?
Your response must be concise. 1.02. What is the ratio of the Expenses (% of total expenses) of Bosnia and Herzegovina in 2005 to that in 2009?
Give a very brief answer. 1.06. What is the ratio of the Expenses (% of total expenses) in Portugal in 2005 to that in 2009?
Offer a very short reply. 0.95. What is the ratio of the Expenses (% of total expenses) in Bangladesh in 2005 to that in 2010?
Give a very brief answer. 1.25. What is the ratio of the Expenses (% of total expenses) of Belarus in 2005 to that in 2010?
Provide a short and direct response. 1.19. What is the ratio of the Expenses (% of total expenses) in Bosnia and Herzegovina in 2005 to that in 2010?
Your answer should be very brief. 1.03. What is the ratio of the Expenses (% of total expenses) in Portugal in 2005 to that in 2010?
Offer a terse response. 0.9. What is the ratio of the Expenses (% of total expenses) in Bangladesh in 2006 to that in 2007?
Provide a succinct answer. 1.12. What is the ratio of the Expenses (% of total expenses) in Belarus in 2006 to that in 2007?
Provide a succinct answer. 1.11. What is the ratio of the Expenses (% of total expenses) in Bosnia and Herzegovina in 2006 to that in 2007?
Give a very brief answer. 1.05. What is the ratio of the Expenses (% of total expenses) of Bangladesh in 2006 to that in 2008?
Offer a terse response. 1.17. What is the ratio of the Expenses (% of total expenses) of Belarus in 2006 to that in 2008?
Your answer should be compact. 1.3. What is the ratio of the Expenses (% of total expenses) of Bosnia and Herzegovina in 2006 to that in 2008?
Your response must be concise. 1.12. What is the ratio of the Expenses (% of total expenses) of Portugal in 2006 to that in 2008?
Your answer should be compact. 0.95. What is the ratio of the Expenses (% of total expenses) of Bangladesh in 2006 to that in 2009?
Provide a succinct answer. 1.17. What is the ratio of the Expenses (% of total expenses) of Belarus in 2006 to that in 2009?
Give a very brief answer. 1.34. What is the ratio of the Expenses (% of total expenses) in Bosnia and Herzegovina in 2006 to that in 2009?
Ensure brevity in your answer.  1.12. What is the ratio of the Expenses (% of total expenses) in Portugal in 2006 to that in 2009?
Your response must be concise. 0.92. What is the ratio of the Expenses (% of total expenses) in Bangladesh in 2006 to that in 2010?
Your answer should be very brief. 1.08. What is the ratio of the Expenses (% of total expenses) in Belarus in 2006 to that in 2010?
Provide a short and direct response. 1.56. What is the ratio of the Expenses (% of total expenses) of Bosnia and Herzegovina in 2006 to that in 2010?
Ensure brevity in your answer.  1.08. What is the ratio of the Expenses (% of total expenses) of Portugal in 2006 to that in 2010?
Your response must be concise. 0.87. What is the ratio of the Expenses (% of total expenses) in Bangladesh in 2007 to that in 2008?
Keep it short and to the point. 1.04. What is the ratio of the Expenses (% of total expenses) of Belarus in 2007 to that in 2008?
Your answer should be very brief. 1.17. What is the ratio of the Expenses (% of total expenses) of Bosnia and Herzegovina in 2007 to that in 2008?
Keep it short and to the point. 1.07. What is the ratio of the Expenses (% of total expenses) of Portugal in 2007 to that in 2008?
Make the answer very short. 0.96. What is the ratio of the Expenses (% of total expenses) in Bangladesh in 2007 to that in 2009?
Ensure brevity in your answer.  1.04. What is the ratio of the Expenses (% of total expenses) in Belarus in 2007 to that in 2009?
Offer a very short reply. 1.21. What is the ratio of the Expenses (% of total expenses) of Bosnia and Herzegovina in 2007 to that in 2009?
Offer a very short reply. 1.06. What is the ratio of the Expenses (% of total expenses) in Portugal in 2007 to that in 2009?
Your response must be concise. 0.93. What is the ratio of the Expenses (% of total expenses) in Bangladesh in 2007 to that in 2010?
Offer a very short reply. 0.96. What is the ratio of the Expenses (% of total expenses) of Belarus in 2007 to that in 2010?
Your response must be concise. 1.41. What is the ratio of the Expenses (% of total expenses) of Bosnia and Herzegovina in 2007 to that in 2010?
Make the answer very short. 1.03. What is the ratio of the Expenses (% of total expenses) in Portugal in 2007 to that in 2010?
Your response must be concise. 0.88. What is the ratio of the Expenses (% of total expenses) of Bangladesh in 2008 to that in 2009?
Provide a succinct answer. 1. What is the ratio of the Expenses (% of total expenses) of Belarus in 2008 to that in 2009?
Keep it short and to the point. 1.03. What is the ratio of the Expenses (% of total expenses) of Portugal in 2008 to that in 2009?
Ensure brevity in your answer.  0.96. What is the ratio of the Expenses (% of total expenses) in Bangladesh in 2008 to that in 2010?
Keep it short and to the point. 0.92. What is the ratio of the Expenses (% of total expenses) in Belarus in 2008 to that in 2010?
Provide a short and direct response. 1.2. What is the ratio of the Expenses (% of total expenses) in Bosnia and Herzegovina in 2008 to that in 2010?
Your response must be concise. 0.96. What is the ratio of the Expenses (% of total expenses) in Portugal in 2008 to that in 2010?
Keep it short and to the point. 0.92. What is the ratio of the Expenses (% of total expenses) of Bangladesh in 2009 to that in 2010?
Give a very brief answer. 0.92. What is the ratio of the Expenses (% of total expenses) of Belarus in 2009 to that in 2010?
Provide a succinct answer. 1.17. What is the ratio of the Expenses (% of total expenses) in Bosnia and Herzegovina in 2009 to that in 2010?
Make the answer very short. 0.97. What is the ratio of the Expenses (% of total expenses) of Portugal in 2009 to that in 2010?
Ensure brevity in your answer.  0.95. What is the difference between the highest and the second highest Expenses (% of total expenses) in Bangladesh?
Make the answer very short. 0.04. What is the difference between the highest and the second highest Expenses (% of total expenses) of Belarus?
Make the answer very short. 3.54. What is the difference between the highest and the second highest Expenses (% of total expenses) of Bosnia and Herzegovina?
Provide a succinct answer. 1.18. What is the difference between the highest and the second highest Expenses (% of total expenses) of Portugal?
Give a very brief answer. 0.38. What is the difference between the highest and the lowest Expenses (% of total expenses) in Bangladesh?
Provide a short and direct response. 4.49. What is the difference between the highest and the lowest Expenses (% of total expenses) in Belarus?
Your answer should be compact. 9.08. What is the difference between the highest and the lowest Expenses (% of total expenses) of Bosnia and Herzegovina?
Offer a terse response. 2.81. What is the difference between the highest and the lowest Expenses (% of total expenses) in Portugal?
Keep it short and to the point. 0.98. 